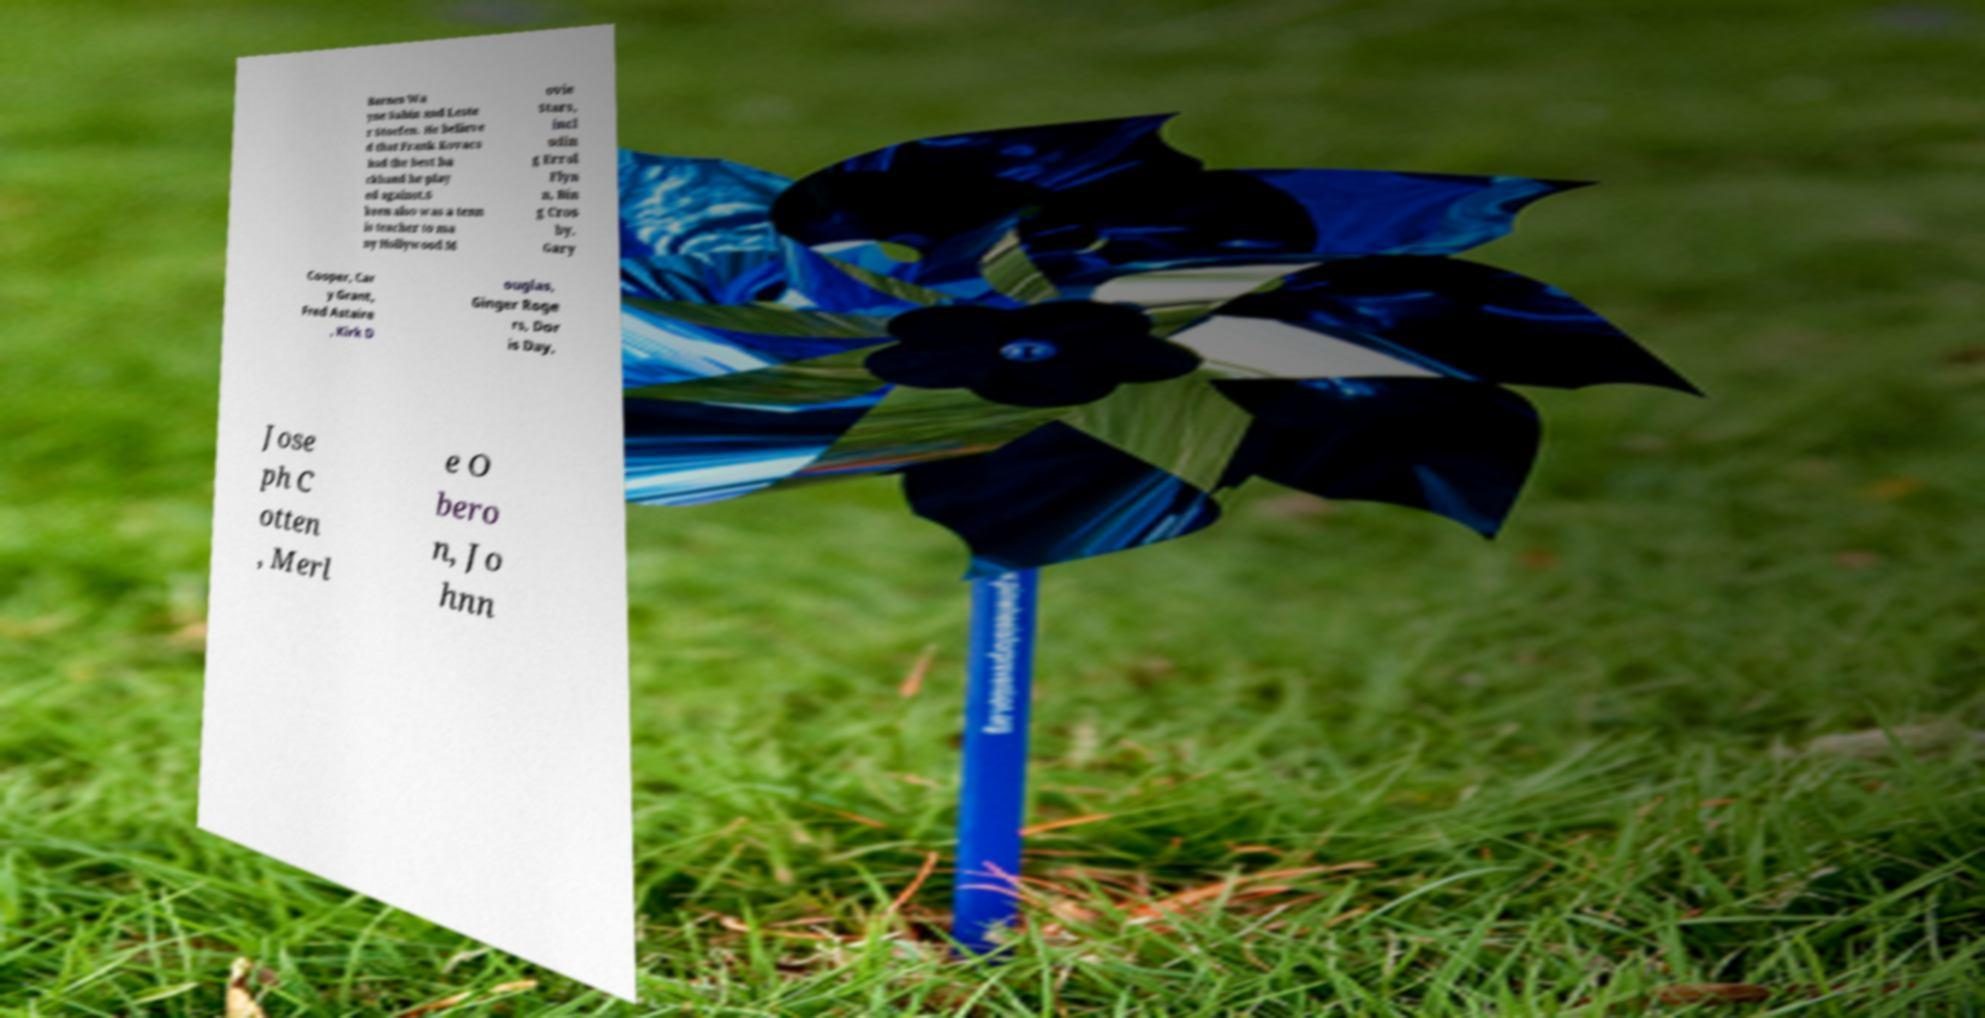Please read and relay the text visible in this image. What does it say? Barnes Wa yne Sabin and Leste r Stoefen. He believe d that Frank Kovacs had the best ba ckhand he play ed against.S keen also was a tenn is teacher to ma ny Hollywood M ovie Stars, incl udin g Errol Flyn n, Bin g Cros by, Gary Cooper, Car y Grant, Fred Astaire , Kirk D ouglas, Ginger Roge rs, Dor is Day, Jose ph C otten , Merl e O bero n, Jo hnn 